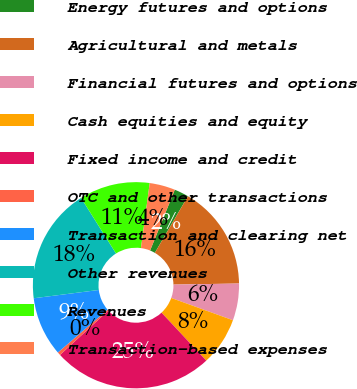Convert chart to OTSL. <chart><loc_0><loc_0><loc_500><loc_500><pie_chart><fcel>Energy futures and options<fcel>Agricultural and metals<fcel>Financial futures and options<fcel>Cash equities and equity<fcel>Fixed income and credit<fcel>OTC and other transactions<fcel>Transaction and clearing net<fcel>Other revenues<fcel>Revenues<fcel>Transaction-based expenses<nl><fcel>2.26%<fcel>16.33%<fcel>5.78%<fcel>7.54%<fcel>25.13%<fcel>0.5%<fcel>9.3%<fcel>18.09%<fcel>11.06%<fcel>4.02%<nl></chart> 